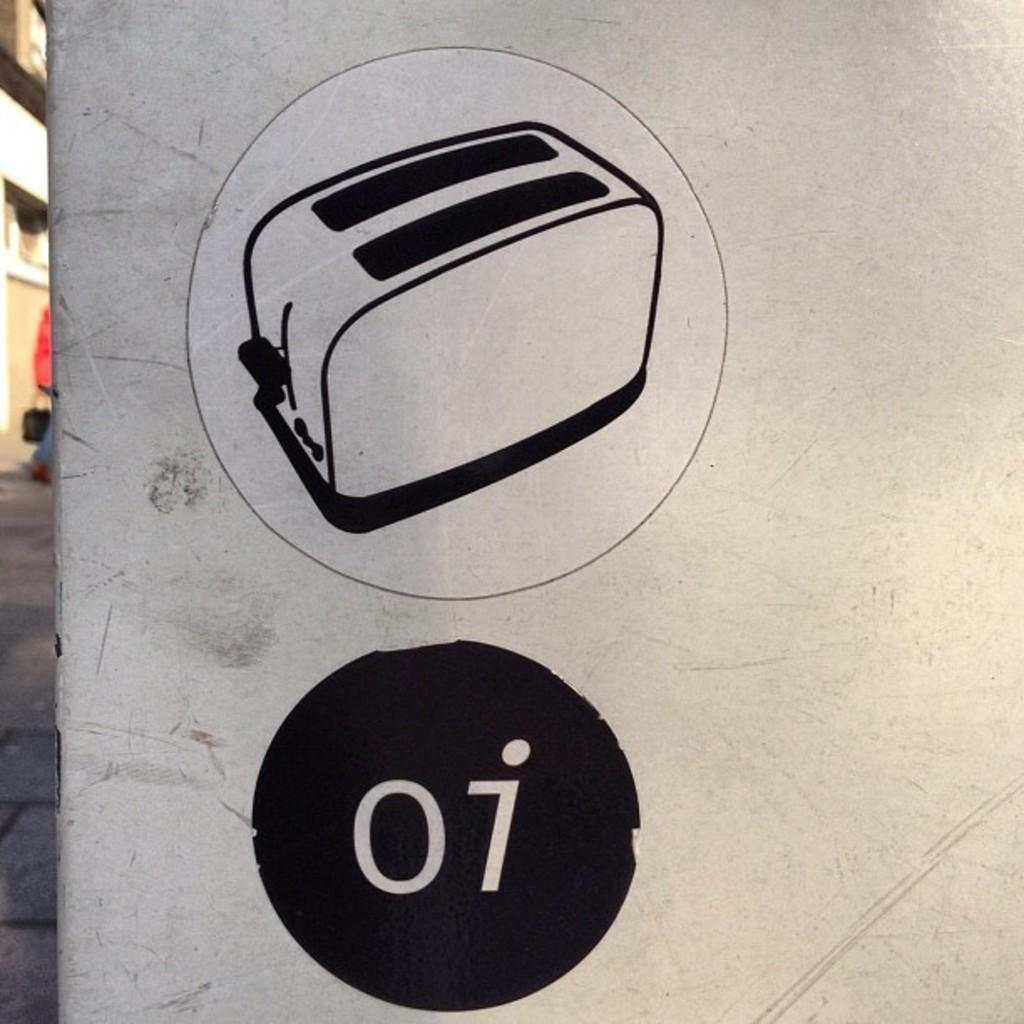How would you summarize this image in a sentence or two? There is a logo and black and white picture of an object in the foreground, it seems like building and a person on the left side. 